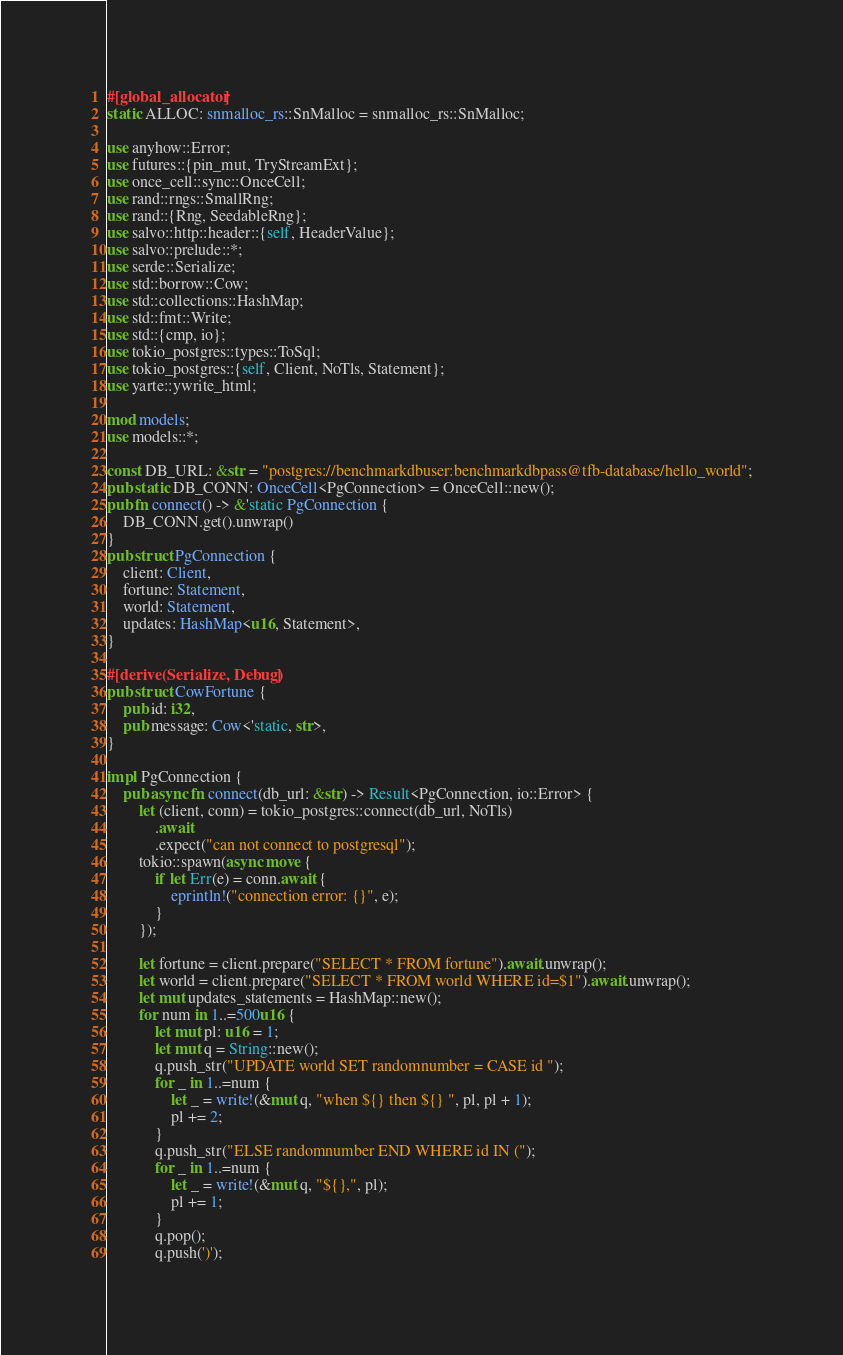<code> <loc_0><loc_0><loc_500><loc_500><_Rust_>#[global_allocator]
static ALLOC: snmalloc_rs::SnMalloc = snmalloc_rs::SnMalloc;

use anyhow::Error;
use futures::{pin_mut, TryStreamExt};
use once_cell::sync::OnceCell;
use rand::rngs::SmallRng;
use rand::{Rng, SeedableRng};
use salvo::http::header::{self, HeaderValue};
use salvo::prelude::*;
use serde::Serialize;
use std::borrow::Cow;
use std::collections::HashMap;
use std::fmt::Write;
use std::{cmp, io};
use tokio_postgres::types::ToSql;
use tokio_postgres::{self, Client, NoTls, Statement};
use yarte::ywrite_html;

mod models;
use models::*;

const DB_URL: &str = "postgres://benchmarkdbuser:benchmarkdbpass@tfb-database/hello_world";
pub static DB_CONN: OnceCell<PgConnection> = OnceCell::new();
pub fn connect() -> &'static PgConnection {
    DB_CONN.get().unwrap()
}
pub struct PgConnection {
    client: Client,
    fortune: Statement,
    world: Statement,
    updates: HashMap<u16, Statement>,
}

#[derive(Serialize, Debug)]
pub struct CowFortune {
    pub id: i32,
    pub message: Cow<'static, str>,
}

impl PgConnection {
    pub async fn connect(db_url: &str) -> Result<PgConnection, io::Error> {
        let (client, conn) = tokio_postgres::connect(db_url, NoTls)
            .await
            .expect("can not connect to postgresql");
        tokio::spawn(async move {
            if let Err(e) = conn.await {
                eprintln!("connection error: {}", e);
            }
        });

        let fortune = client.prepare("SELECT * FROM fortune").await.unwrap();
        let world = client.prepare("SELECT * FROM world WHERE id=$1").await.unwrap();
        let mut updates_statements = HashMap::new();
        for num in 1..=500u16 {
            let mut pl: u16 = 1;
            let mut q = String::new();
            q.push_str("UPDATE world SET randomnumber = CASE id ");
            for _ in 1..=num {
                let _ = write!(&mut q, "when ${} then ${} ", pl, pl + 1);
                pl += 2;
            }
            q.push_str("ELSE randomnumber END WHERE id IN (");
            for _ in 1..=num {
                let _ = write!(&mut q, "${},", pl);
                pl += 1;
            }
            q.pop();
            q.push(')');</code> 